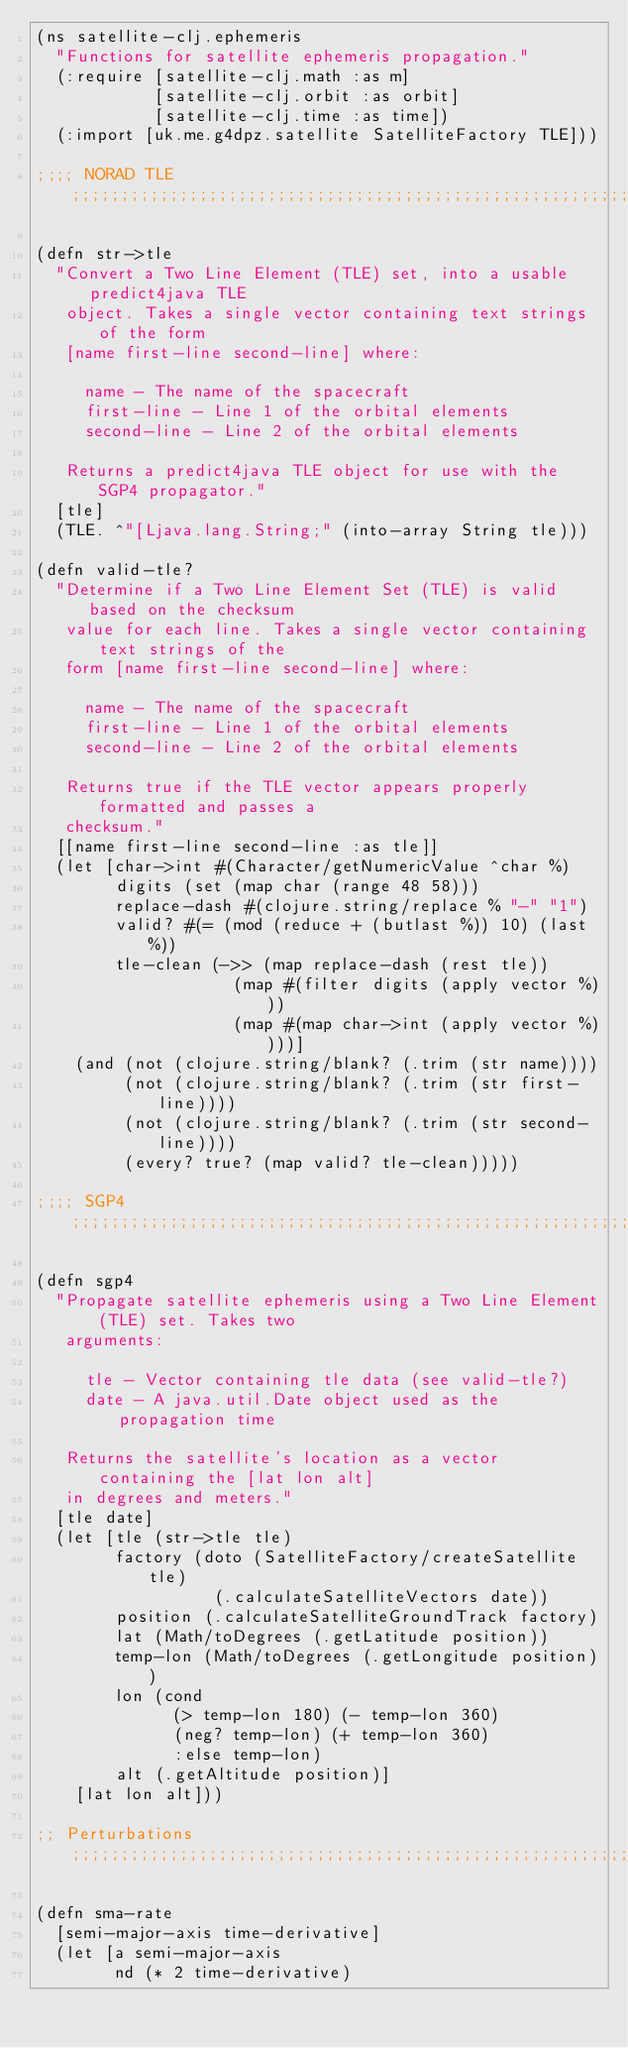<code> <loc_0><loc_0><loc_500><loc_500><_Clojure_>(ns satellite-clj.ephemeris
  "Functions for satellite ephemeris propagation."
  (:require [satellite-clj.math :as m]
            [satellite-clj.orbit :as orbit]
            [satellite-clj.time :as time])
  (:import [uk.me.g4dpz.satellite SatelliteFactory TLE]))

;;;; NORAD TLE ;;;;;;;;;;;;;;;;;;;;;;;;;;;;;;;;;;;;;;;;;;;;;;;;;;;;;;;;;;;;;;;;;

(defn str->tle
  "Convert a Two Line Element (TLE) set, into a usable predict4java TLE
   object. Takes a single vector containing text strings of the form
   [name first-line second-line] where:

     name - The name of the spacecraft  
     first-line - Line 1 of the orbital elements  
     second-line - Line 2 of the orbital elements

   Returns a predict4java TLE object for use with the SGP4 propagator."
  [tle]
  (TLE. ^"[Ljava.lang.String;" (into-array String tle)))

(defn valid-tle?
  "Determine if a Two Line Element Set (TLE) is valid based on the checksum
   value for each line. Takes a single vector containing text strings of the
   form [name first-line second-line] where:

     name - The name of the spacecraft  
     first-line - Line 1 of the orbital elements  
     second-line - Line 2 of the orbital elements

   Returns true if the TLE vector appears properly formatted and passes a
   checksum."
  [[name first-line second-line :as tle]]
  (let [char->int #(Character/getNumericValue ^char %)
        digits (set (map char (range 48 58)))
        replace-dash #(clojure.string/replace % "-" "1")
        valid? #(= (mod (reduce + (butlast %)) 10) (last %))
        tle-clean (->> (map replace-dash (rest tle))
                    (map #(filter digits (apply vector %)))
                    (map #(map char->int (apply vector %))))]
    (and (not (clojure.string/blank? (.trim (str name))))
         (not (clojure.string/blank? (.trim (str first-line))))
         (not (clojure.string/blank? (.trim (str second-line))))
         (every? true? (map valid? tle-clean)))))

;;;; SGP4 ;;;;;;;;;;;;;;;;;;;;;;;;;;;;;;;;;;;;;;;;;;;;;;;;;;;;;;;;;;;;;;;;;;;;;;

(defn sgp4
  "Propagate satellite ephemeris using a Two Line Element (TLE) set. Takes two
   arguments:

     tle - Vector containing tle data (see valid-tle?)  
     date - A java.util.Date object used as the propagation time

   Returns the satellite's location as a vector containing the [lat lon alt]
   in degrees and meters."
  [tle date]
  (let [tle (str->tle tle)
        factory (doto (SatelliteFactory/createSatellite tle)
                  (.calculateSatelliteVectors date))
        position (.calculateSatelliteGroundTrack factory)
        lat (Math/toDegrees (.getLatitude position))
        temp-lon (Math/toDegrees (.getLongitude position))
        lon (cond
              (> temp-lon 180) (- temp-lon 360)
              (neg? temp-lon) (+ temp-lon 360)
              :else temp-lon)
        alt (.getAltitude position)]
    [lat lon alt]))

;; Perturbations ;;;;;;;;;;;;;;;;;;;;;;;;;;;;;;;;;;;;;;;;;;;;;;;;;;;;;;;;;;;;;;;

(defn sma-rate
  [semi-major-axis time-derivative]
  (let [a semi-major-axis
        nd (* 2 time-derivative)</code> 